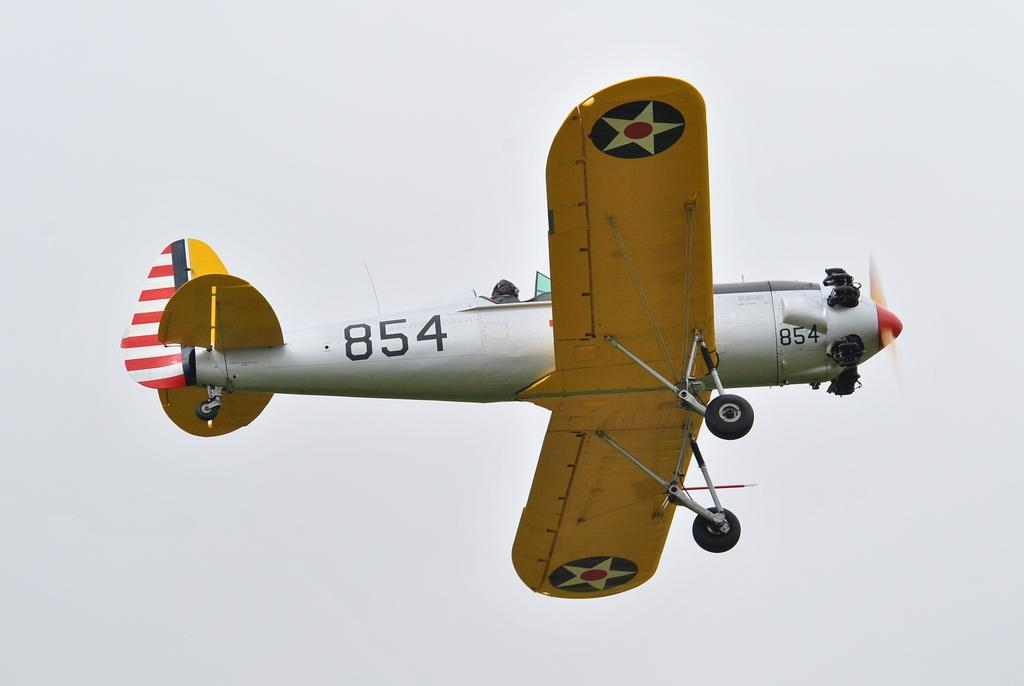What is the main subject of the picture? The main subject of the picture is an airplane. What is the airplane doing in the image? The airplane is flying in the air. What can be seen in the background of the image? There is a sky visible in the background of the image. Is there any text or symbols on the airplane? Yes, there is something written on the airplane. What type of watch can be seen on the airplane's wing in the image? There is no watch visible on the airplane's wing in the image. How is the furniture arranged inside the airplane in the image? There is no furniture present inside the airplane in the image. 